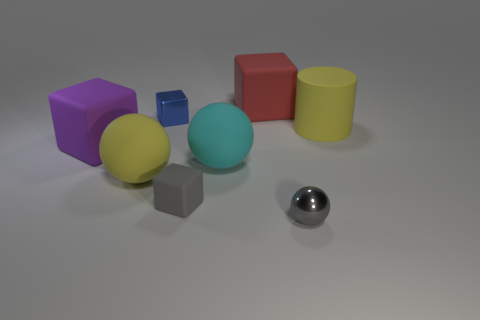Does the cyan thing have the same shape as the gray metal object?
Your response must be concise. Yes. What color is the small metallic object that is the same shape as the small matte object?
Your response must be concise. Blue. Is there a yellow matte thing of the same shape as the cyan matte thing?
Ensure brevity in your answer.  Yes. There is a red rubber object that is the same size as the purple rubber object; what shape is it?
Make the answer very short. Cube. What material is the cyan sphere?
Your answer should be compact. Rubber. How big is the cyan matte thing behind the big rubber sphere that is on the left side of the small cube that is behind the cylinder?
Offer a very short reply. Large. There is a thing that is the same color as the tiny rubber cube; what is its material?
Give a very brief answer. Metal. How many matte objects are either gray cubes or things?
Offer a terse response. 6. What size is the cyan sphere?
Your answer should be compact. Large. How many objects are either big purple metallic spheres or large objects that are left of the big yellow cylinder?
Your answer should be compact. 4. 